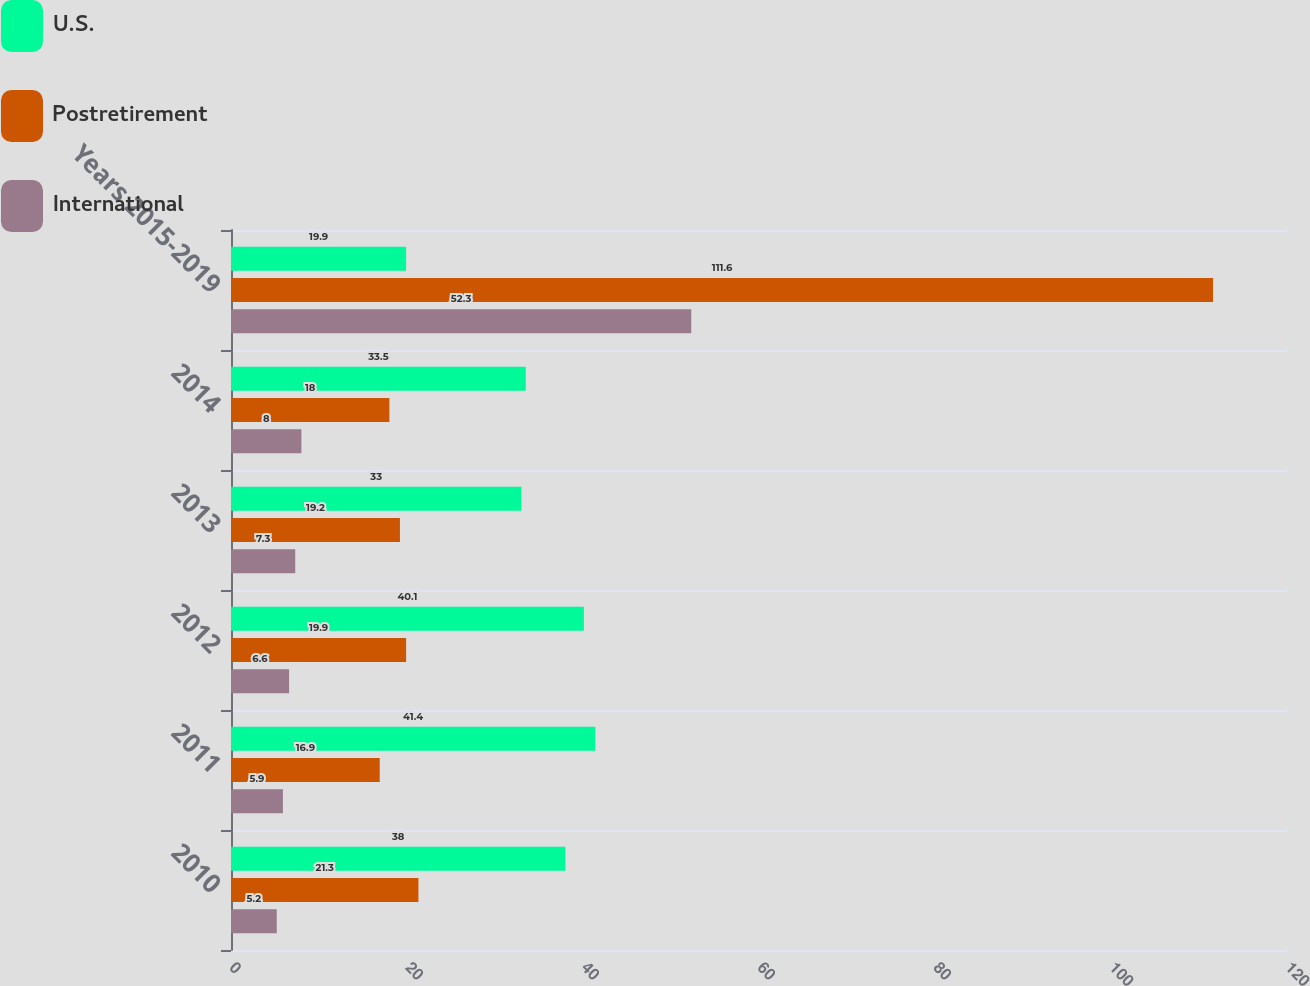Convert chart to OTSL. <chart><loc_0><loc_0><loc_500><loc_500><stacked_bar_chart><ecel><fcel>2010<fcel>2011<fcel>2012<fcel>2013<fcel>2014<fcel>Years 2015-2019<nl><fcel>U.S.<fcel>38<fcel>41.4<fcel>40.1<fcel>33<fcel>33.5<fcel>19.9<nl><fcel>Postretirement<fcel>21.3<fcel>16.9<fcel>19.9<fcel>19.2<fcel>18<fcel>111.6<nl><fcel>International<fcel>5.2<fcel>5.9<fcel>6.6<fcel>7.3<fcel>8<fcel>52.3<nl></chart> 